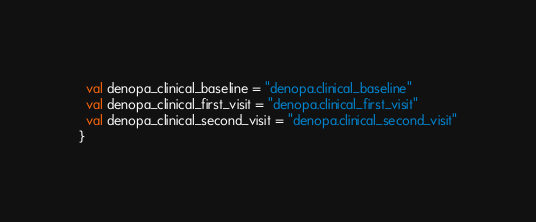<code> <loc_0><loc_0><loc_500><loc_500><_Scala_>  val denopa_clinical_baseline = "denopa.clinical_baseline"
  val denopa_clinical_first_visit = "denopa.clinical_first_visit"
  val denopa_clinical_second_visit = "denopa.clinical_second_visit"
}
</code> 